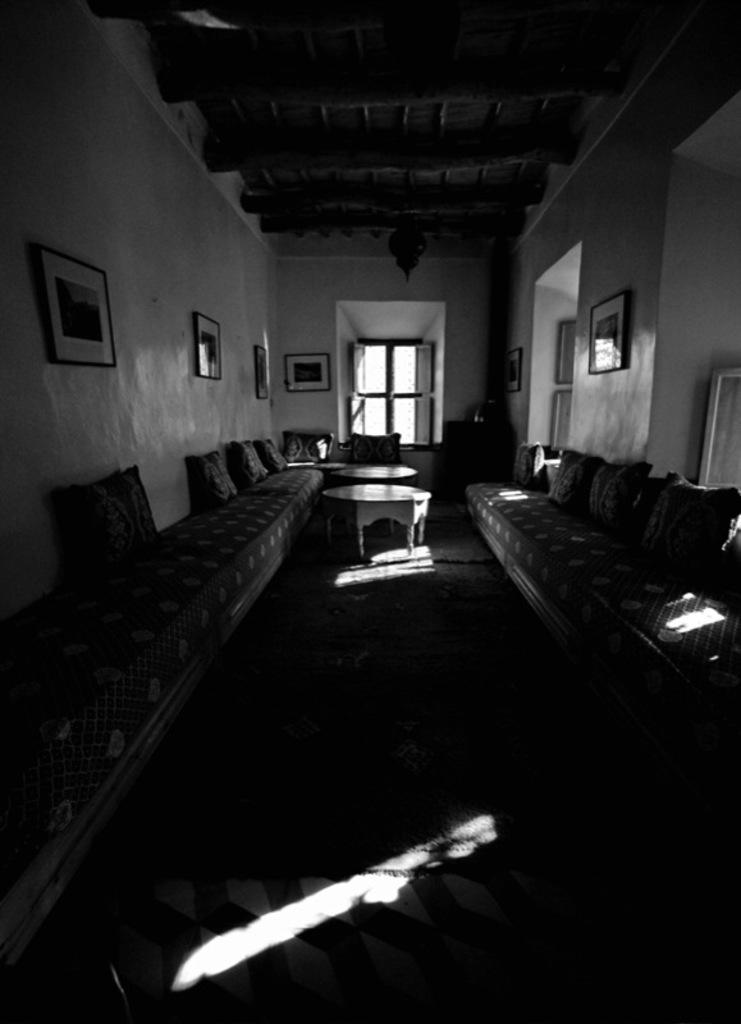Describe this image in one or two sentences. In this picture there is a inside view of the hall. On both the side we can see sofa and around table in the center. In the background we can see the white wall with photo frames and a big window. 